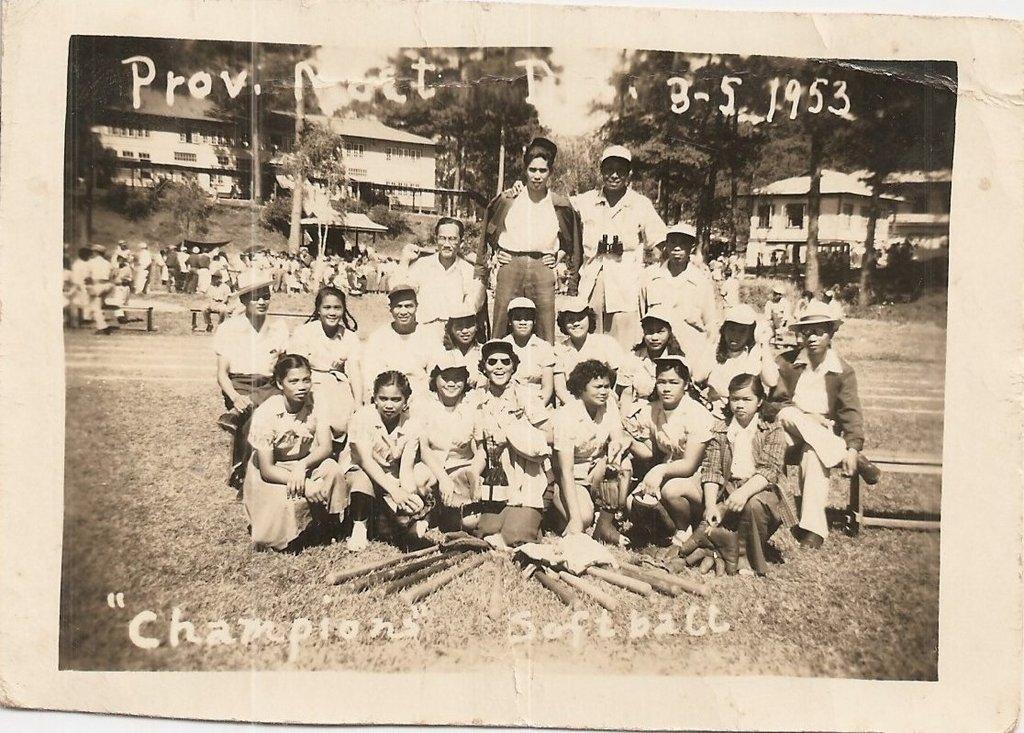Describe this image in one or two sentences. In this image I can see an open ground and on it I can see number of people where few are sitting and few are standing. In the background I can see few buildings, number of trees and in the front I can see few wooden sticks on the ground. I can also see something is written on the top and on the bottom side of the image. I can also see this image is of a photo frame. 